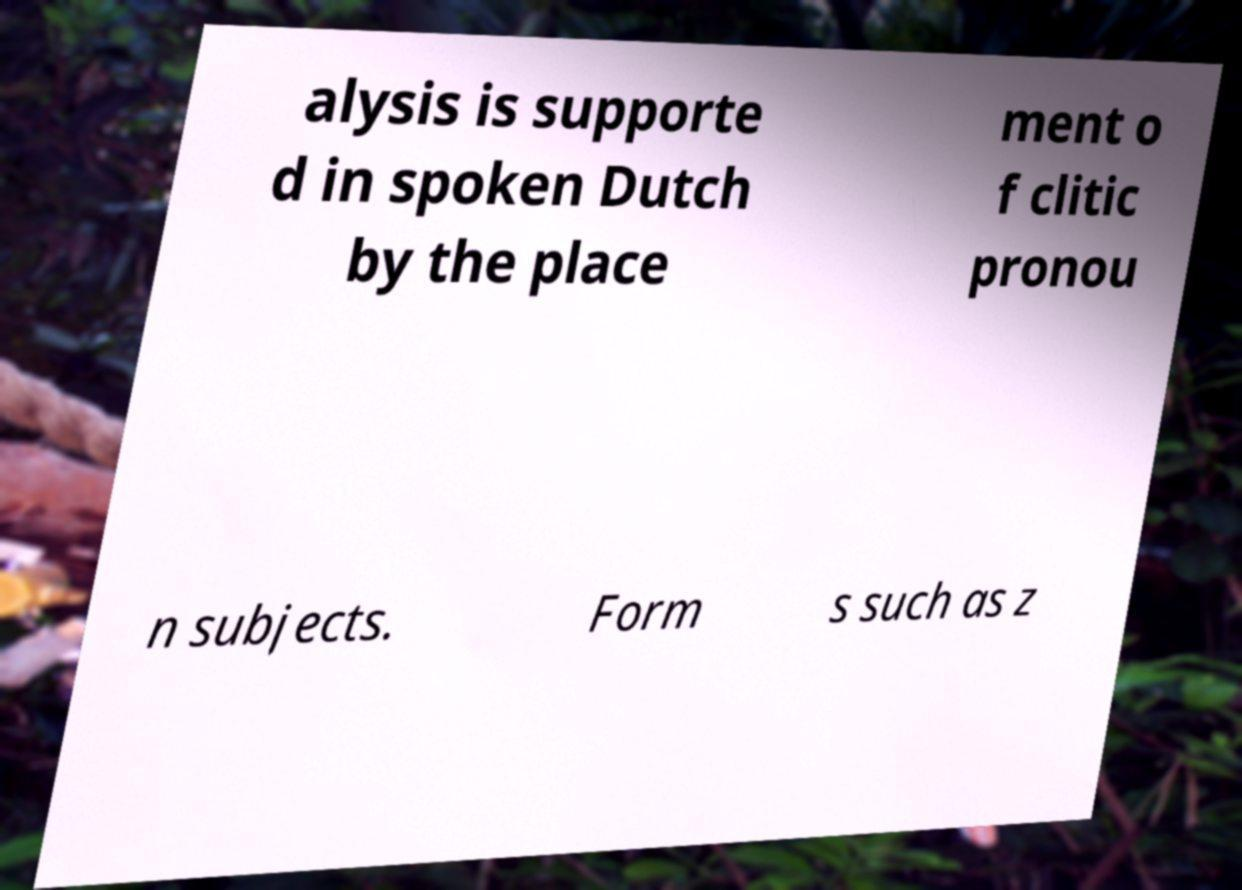I need the written content from this picture converted into text. Can you do that? alysis is supporte d in spoken Dutch by the place ment o f clitic pronou n subjects. Form s such as z 